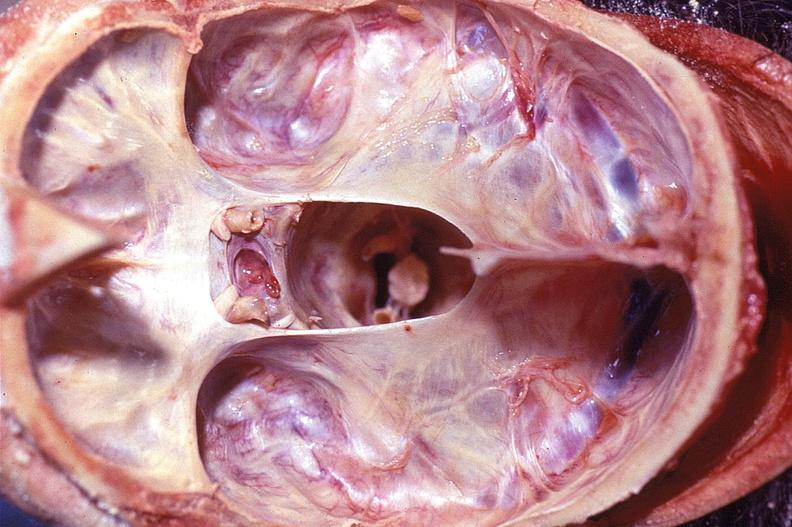what is present?
Answer the question using a single word or phrase. Nervous 